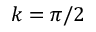<formula> <loc_0><loc_0><loc_500><loc_500>k = \pi / 2</formula> 